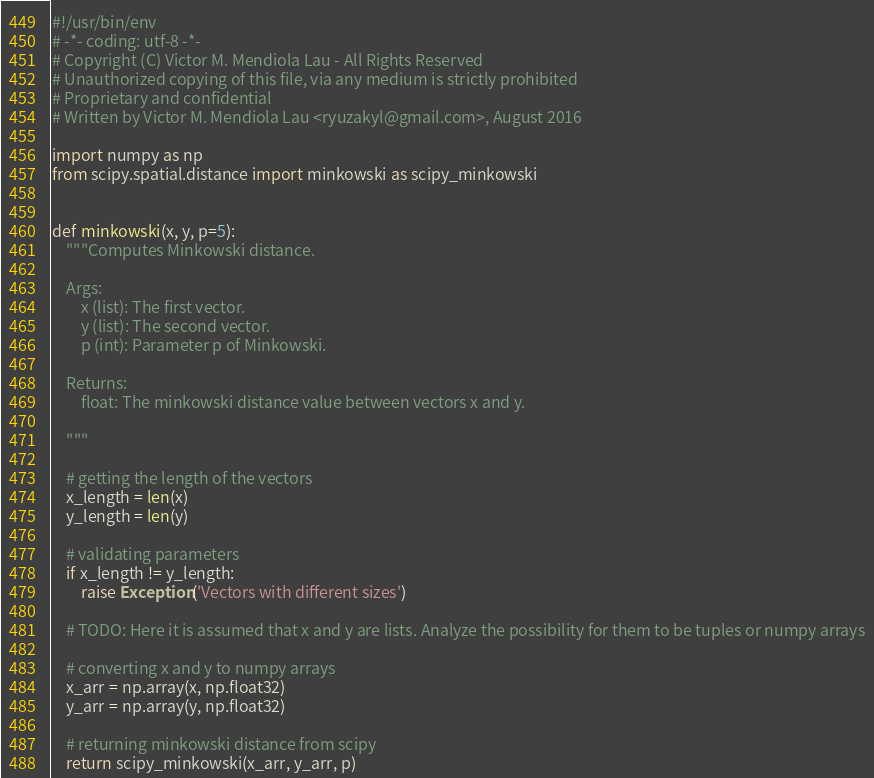<code> <loc_0><loc_0><loc_500><loc_500><_Python_>#!/usr/bin/env
# -*- coding: utf-8 -*-
# Copyright (C) Victor M. Mendiola Lau - All Rights Reserved
# Unauthorized copying of this file, via any medium is strictly prohibited
# Proprietary and confidential
# Written by Victor M. Mendiola Lau <ryuzakyl@gmail.com>, August 2016

import numpy as np
from scipy.spatial.distance import minkowski as scipy_minkowski


def minkowski(x, y, p=5):
    """Computes Minkowski distance.

    Args:
        x (list): The first vector.
        y (list): The second vector.
        p (int): Parameter p of Minkowski.

    Returns:
        float: The minkowski distance value between vectors x and y.

    """

    # getting the length of the vectors
    x_length = len(x)
    y_length = len(y)

    # validating parameters
    if x_length != y_length:
        raise Exception('Vectors with different sizes')

    # TODO: Here it is assumed that x and y are lists. Analyze the possibility for them to be tuples or numpy arrays

    # converting x and y to numpy arrays
    x_arr = np.array(x, np.float32)
    y_arr = np.array(y, np.float32)

    # returning minkowski distance from scipy
    return scipy_minkowski(x_arr, y_arr, p)
</code> 